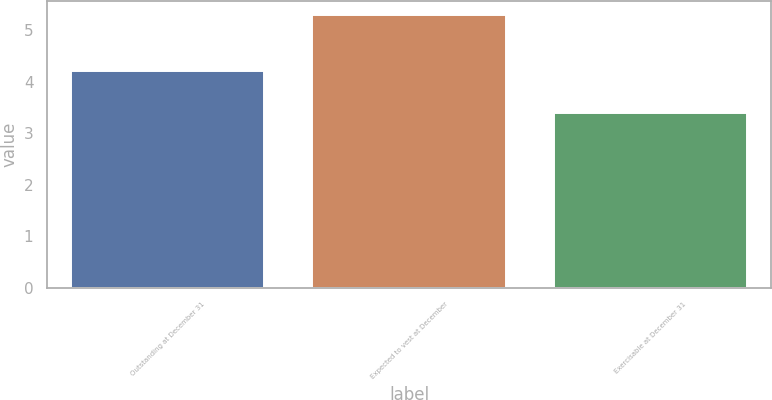Convert chart. <chart><loc_0><loc_0><loc_500><loc_500><bar_chart><fcel>Outstanding at December 31<fcel>Expected to vest at December<fcel>Exercisable at December 31<nl><fcel>4.2<fcel>5.3<fcel>3.4<nl></chart> 